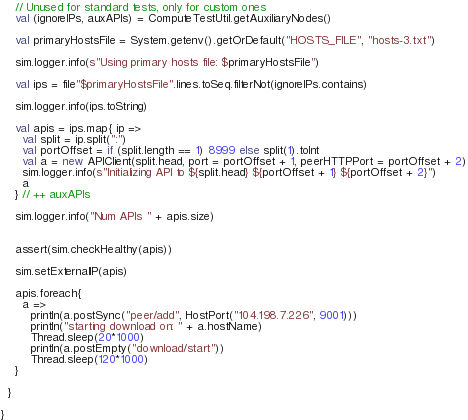Convert code to text. <code><loc_0><loc_0><loc_500><loc_500><_Scala_>    // Unused for standard tests, only for custom ones
    val (ignoreIPs, auxAPIs) = ComputeTestUtil.getAuxiliaryNodes()

    val primaryHostsFile = System.getenv().getOrDefault("HOSTS_FILE", "hosts-3.txt")

    sim.logger.info(s"Using primary hosts file: $primaryHostsFile")

    val ips = file"$primaryHostsFile".lines.toSeq.filterNot(ignoreIPs.contains)

    sim.logger.info(ips.toString)

    val apis = ips.map{ ip =>
      val split = ip.split(":")
      val portOffset = if (split.length == 1) 8999 else split(1).toInt
      val a = new APIClient(split.head, port = portOffset + 1, peerHTTPPort = portOffset + 2)
      sim.logger.info(s"Initializing API to ${split.head} ${portOffset + 1} ${portOffset + 2}")
      a
    } // ++ auxAPIs

    sim.logger.info("Num APIs " + apis.size)


    assert(sim.checkHealthy(apis))

    sim.setExternalIP(apis)

    apis.foreach{
      a =>
        println(a.postSync("peer/add", HostPort("104.198.7.226", 9001)))
        println("starting download on: " + a.hostName)
        Thread.sleep(20*1000)
        println(a.postEmpty("download/start"))
        Thread.sleep(120*1000)
    }

  }

}
</code> 